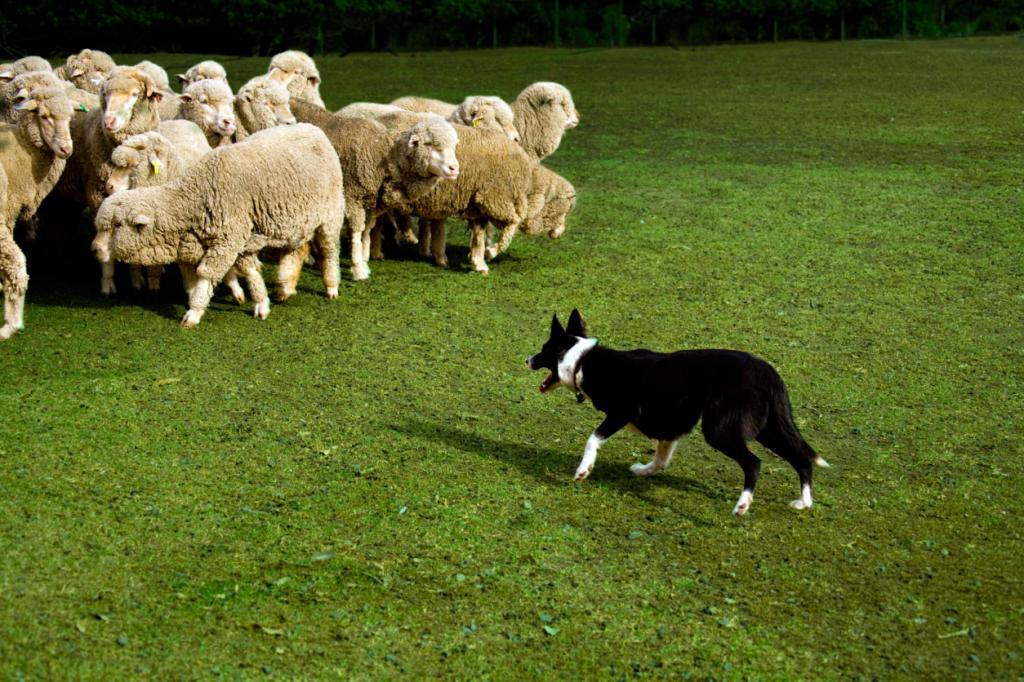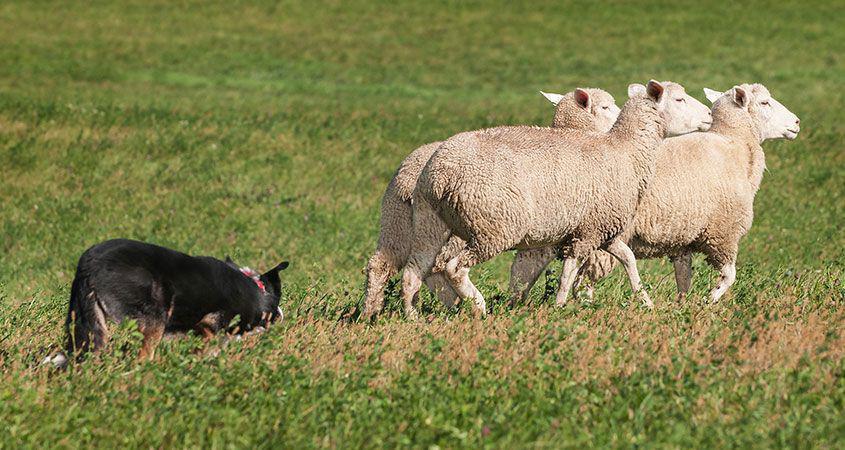The first image is the image on the left, the second image is the image on the right. Examine the images to the left and right. Is the description "The right photo contains exactly three sheep." accurate? Answer yes or no. Yes. The first image is the image on the left, the second image is the image on the right. Analyze the images presented: Is the assertion "Some of the animals are near a wooden fence." valid? Answer yes or no. No. 